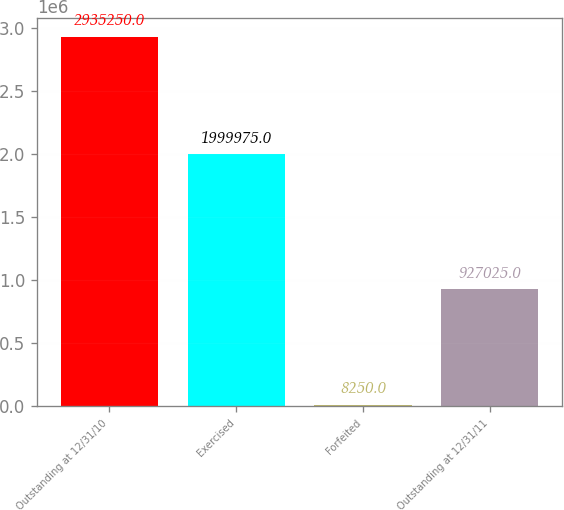Convert chart. <chart><loc_0><loc_0><loc_500><loc_500><bar_chart><fcel>Outstanding at 12/31/10<fcel>Exercised<fcel>Forfeited<fcel>Outstanding at 12/31/11<nl><fcel>2.93525e+06<fcel>1.99998e+06<fcel>8250<fcel>927025<nl></chart> 